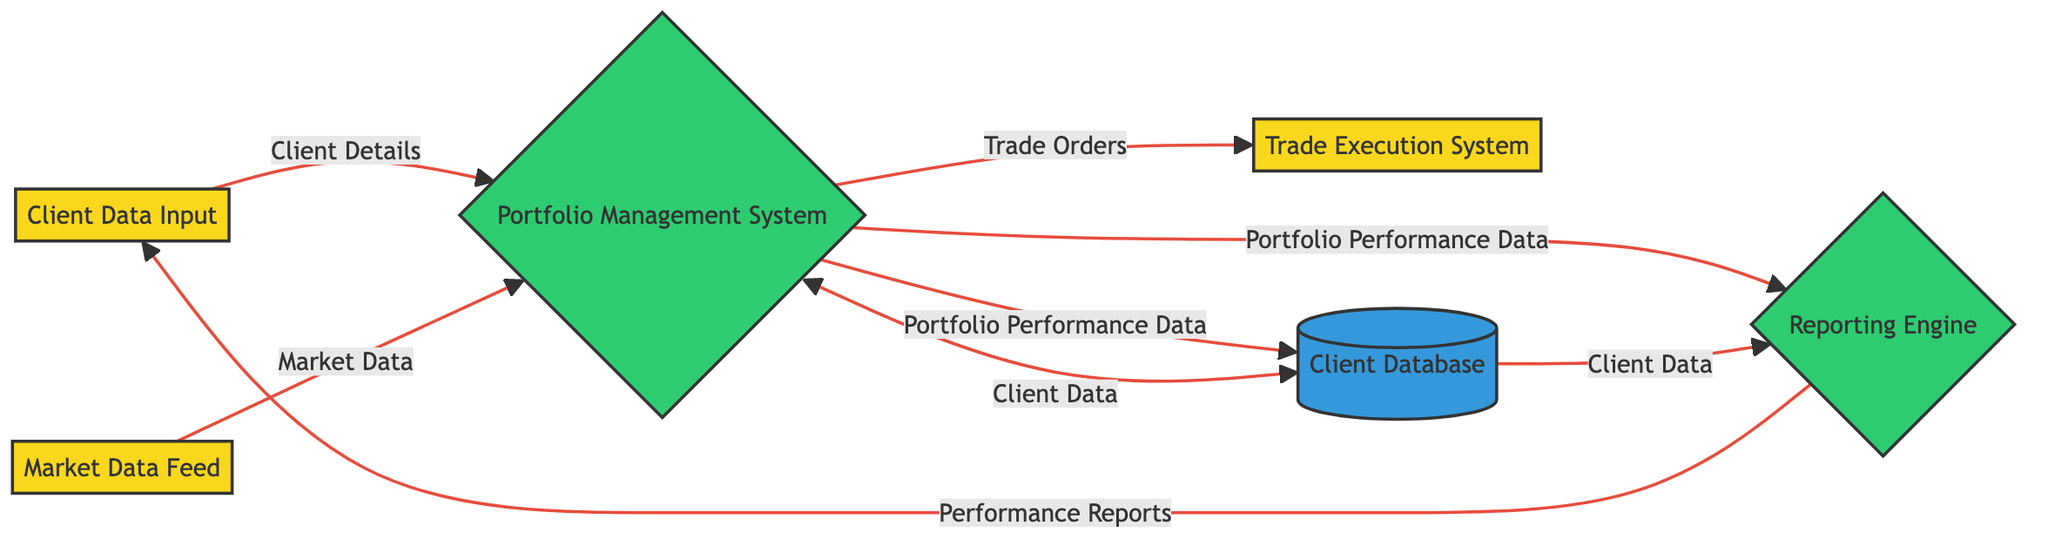What are the inputs to the Portfolio Management System? The inputs to the Portfolio Management System are listed as Client Data Input, Market Data Feed, and Client Database. This can be directly identified from the arrows leading into the Portfolio Management System.
Answer: Client Data Input, Market Data Feed, Client Database How many external entities are present in the diagram? The diagram shows three external entities: Client Data Input, Market Data Feed, and Trade Execution System, each defined by a specific color and shape. Counting these entities provides the total number.
Answer: 3 What does the Trade Orders data flow contain? The Trade Orders data flow contains buy and sell orders based on portfolio adjustments, as detailed in the description of the data flow connecting the Portfolio Management System to the Trade Execution System.
Answer: Buy and sell orders Which entity generates Performance Reports? The Reporting Engine generates Performance Reports, as shown by the output connection leading from the Reporting Engine to the Client Data Input. This connection indicates that the Reporting Engine processes inputs to produce these reports.
Answer: Reporting Engine What are the outputs of the Portfolio Management System? The outputs of the Portfolio Management System include Portfolio Performance Data and Trade Orders. This information is available in the output declarations linked to the Portfolio Management System in the diagram.
Answer: Portfolio Performance Data, Trade Orders How does Portfolio Performance Data move through the system? Portfolio Performance Data is generated by the Portfolio Management System and moves to both the Reporting Engine and the Client Database. Each connection can be traced from the output of the Portfolio Management System to these two destinations.
Answer: To Reporting Engine and Client Database Which data stores do the Reporting Engine rely on? The Reporting Engine relies on the Client Database for client data and receives Portfolio Performance Data from the Portfolio Management System. These relationships are shown by the arrows linking the relevant data flows to the Reporting Engine.
Answer: Client Database What is the final destination for the Performance Reports? The final destination for the Performance Reports is the Client Data Input, as indicated by the directional arrow that shows how performance reports flow from the Reporting Engine to this external entity.
Answer: Client Data Input What connects the Portfolio Management System to the Trade Execution System? The connection that links the Portfolio Management System to the Trade Execution System is through the Trade Orders data flow, which carries the buy and sell orders based on portfolio adjustments.
Answer: Trade Orders data flow 